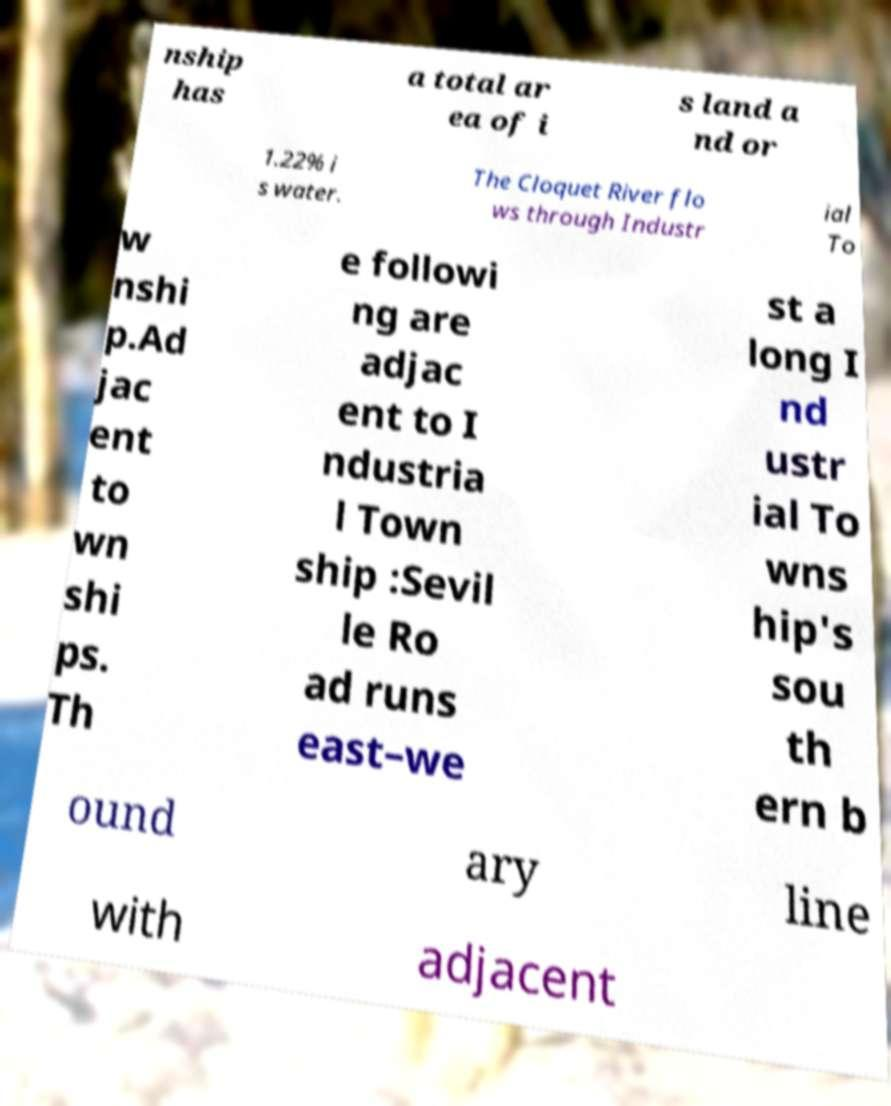Please read and relay the text visible in this image. What does it say? nship has a total ar ea of i s land a nd or 1.22% i s water. The Cloquet River flo ws through Industr ial To w nshi p.Ad jac ent to wn shi ps. Th e followi ng are adjac ent to I ndustria l Town ship :Sevil le Ro ad runs east–we st a long I nd ustr ial To wns hip's sou th ern b ound ary line with adjacent 